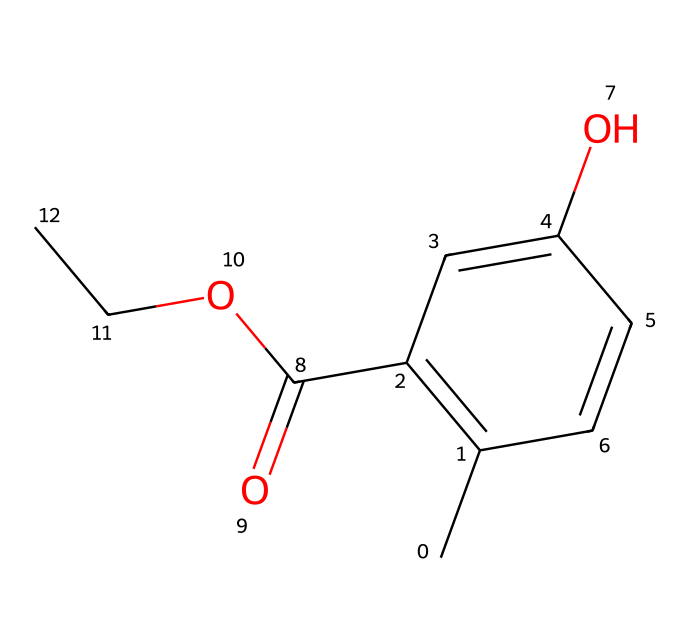how many carbon atoms are in this chemical? By examining the provided SMILES structure, we see the symbols 'C' which represent carbon atoms. There are a total of 9 'C' symbols in the represented structure, indicating there are 9 carbon atoms in the molecule.
Answer: 9 what is the functional group present in this structure? The SMILES representation includes a hydroxyl group ('O') represented in the structure as 'O' attached to a carbon chain, indicating the presence of an alcohol functional group. Moreover, the 'C(=O)O' suggests a carboxylic acid group is also present in this compound.
Answer: alcohol and carboxylic acid what is the total number of oxygen atoms in the molecule? Analyzing the SMILES representation shows us two distinct oxygen elements: one in the hydroxyl group and two in the carboxylic acid group. Counting these yields a total of 3 oxygen atoms in the structure.
Answer: 3 does this molecule have any double bonds? Looking closely at the structural representation, we can see that there are double bonds present between the carbon atoms (C=C) in the aromatic ring and between the carbon and oxygen in the carboxylic acid group (C=O).
Answer: yes what type of isomerism could this compound potentially exhibit? Given its structural makeup, the presence of cis-trans isomerism is possible due to the double bonds found in the carbon chain, allowing for the arrangement of substituents on either side of the double bond in the aromatic ring.
Answer: cis-trans isomerism how does the presence of the hydroxyl group affect the solubility of this compound? The hydroxyl group presents in the molecule is hydrophilic due to its ability to form hydrogen bonds with water molecules, which enhances the solubility of this molecule in polar solvents, such as water.
Answer: increases solubility 